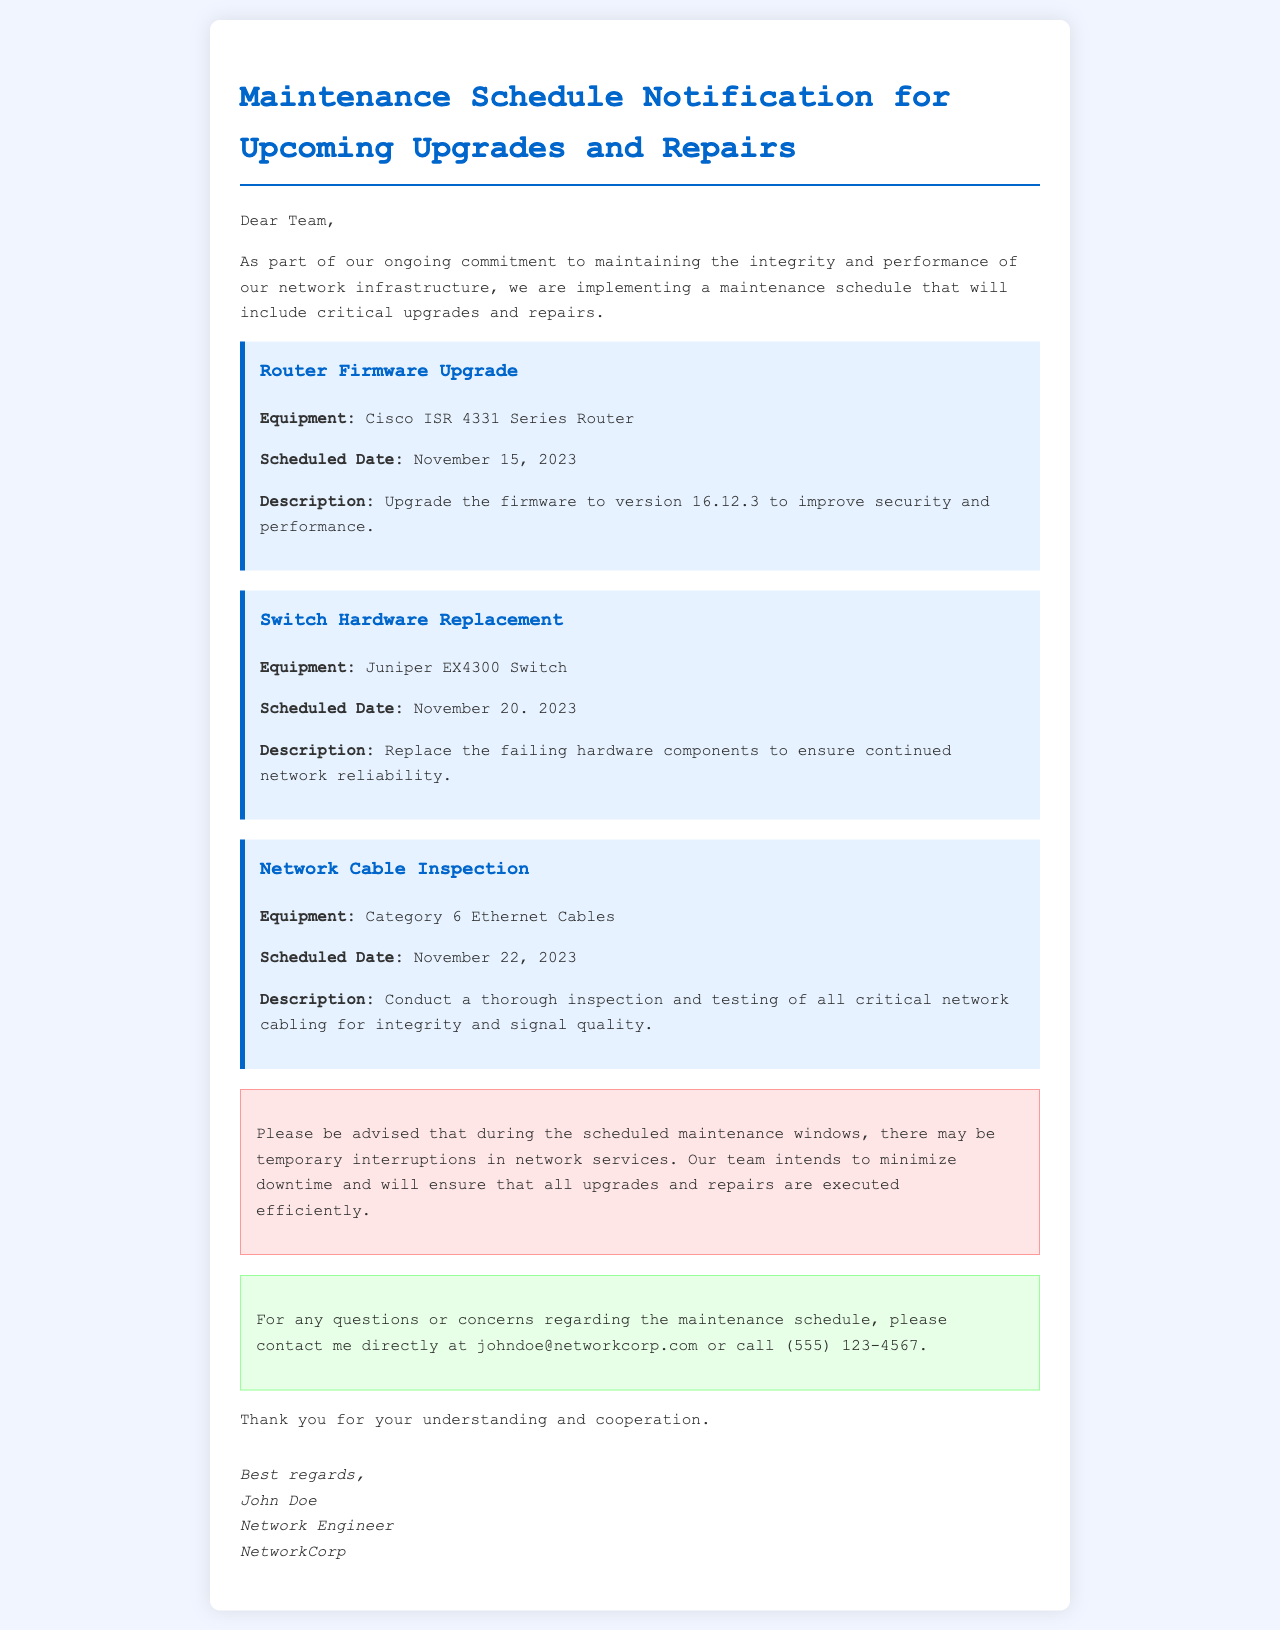What is the scheduled date for the Router Firmware Upgrade? The scheduled date for the Router Firmware Upgrade is listed under the corresponding task in the document.
Answer: November 15, 2023 What is the equipment involved in the Switch Hardware Replacement? The document specifies the equipment for the Switch Hardware Replacement.
Answer: Juniper EX4300 Switch What is the description of the Network Cable Inspection? The description is provided in the task regarding Network Cable Inspection in the document.
Answer: Conduct a thorough inspection and testing of all critical network cabling for integrity and signal quality How many scheduled maintenance tasks are listed in the document? The number of tasks can be determined by counting the different tasks mentioned in the document.
Answer: Three What should team members expect during the scheduled maintenance windows? The document states the implications of the scheduled maintenance, providing information on what to expect.
Answer: Temporary interruptions in network services Who should be contacted for questions or concerns about the maintenance schedule? The document includes a section with contact information for inquiries regarding the maintenance schedule.
Answer: John Doe What is the purpose of the maintenance schedule mentioned in the document? The purpose of the maintenance schedule is explained at the beginning of the document.
Answer: Maintaining the integrity and performance of our network infrastructure What is the color of the task boxes in the document? The color of the task boxes is described in the styling provided for the document.
Answer: Light blue 